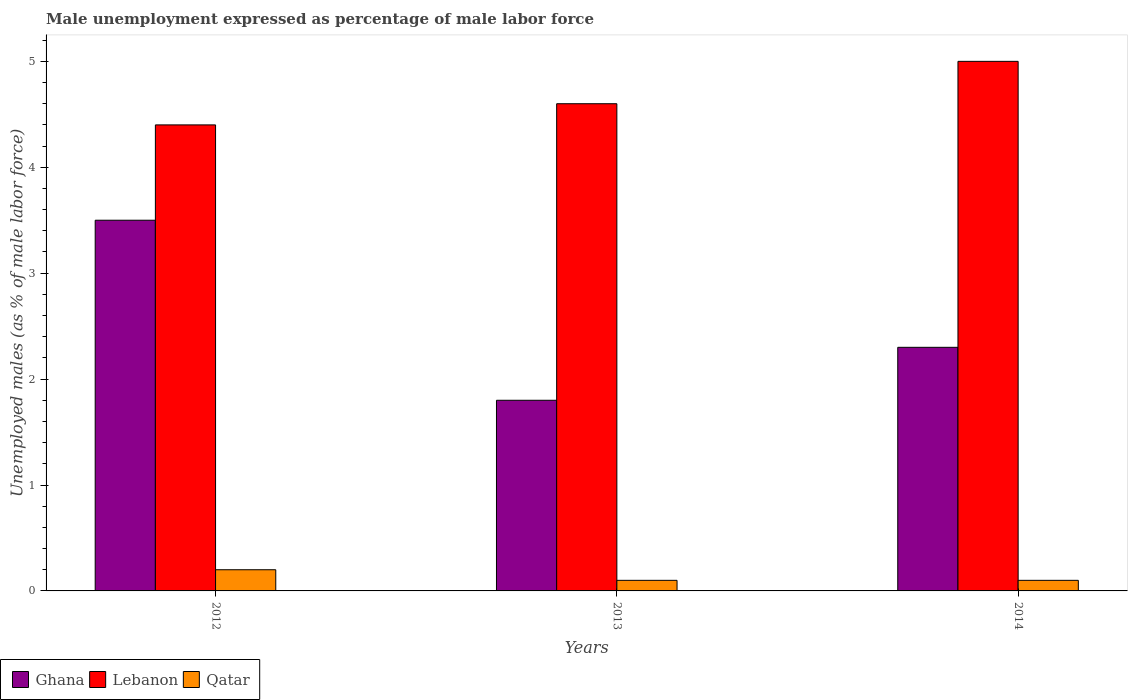How many groups of bars are there?
Your answer should be compact. 3. Are the number of bars on each tick of the X-axis equal?
Provide a succinct answer. Yes. What is the label of the 2nd group of bars from the left?
Your response must be concise. 2013. What is the unemployment in males in in Qatar in 2014?
Keep it short and to the point. 0.1. Across all years, what is the maximum unemployment in males in in Lebanon?
Your response must be concise. 5. Across all years, what is the minimum unemployment in males in in Lebanon?
Ensure brevity in your answer.  4.4. In which year was the unemployment in males in in Lebanon maximum?
Make the answer very short. 2014. What is the total unemployment in males in in Lebanon in the graph?
Offer a very short reply. 14. What is the difference between the unemployment in males in in Qatar in 2012 and that in 2014?
Make the answer very short. 0.1. What is the difference between the unemployment in males in in Ghana in 2012 and the unemployment in males in in Qatar in 2013?
Your answer should be compact. 3.4. What is the average unemployment in males in in Ghana per year?
Keep it short and to the point. 2.53. In the year 2013, what is the difference between the unemployment in males in in Ghana and unemployment in males in in Lebanon?
Ensure brevity in your answer.  -2.8. In how many years, is the unemployment in males in in Lebanon greater than 0.4 %?
Your answer should be compact. 3. What is the ratio of the unemployment in males in in Ghana in 2013 to that in 2014?
Give a very brief answer. 0.78. Is the unemployment in males in in Qatar in 2012 less than that in 2014?
Ensure brevity in your answer.  No. What is the difference between the highest and the second highest unemployment in males in in Ghana?
Keep it short and to the point. 1.2. What is the difference between the highest and the lowest unemployment in males in in Ghana?
Keep it short and to the point. 1.7. In how many years, is the unemployment in males in in Ghana greater than the average unemployment in males in in Ghana taken over all years?
Your answer should be compact. 1. What does the 3rd bar from the left in 2012 represents?
Ensure brevity in your answer.  Qatar. What does the 3rd bar from the right in 2014 represents?
Keep it short and to the point. Ghana. How many bars are there?
Ensure brevity in your answer.  9. Are all the bars in the graph horizontal?
Provide a succinct answer. No. How many years are there in the graph?
Give a very brief answer. 3. Does the graph contain any zero values?
Provide a short and direct response. No. How are the legend labels stacked?
Give a very brief answer. Horizontal. What is the title of the graph?
Give a very brief answer. Male unemployment expressed as percentage of male labor force. What is the label or title of the X-axis?
Ensure brevity in your answer.  Years. What is the label or title of the Y-axis?
Keep it short and to the point. Unemployed males (as % of male labor force). What is the Unemployed males (as % of male labor force) of Ghana in 2012?
Ensure brevity in your answer.  3.5. What is the Unemployed males (as % of male labor force) of Lebanon in 2012?
Provide a succinct answer. 4.4. What is the Unemployed males (as % of male labor force) in Qatar in 2012?
Give a very brief answer. 0.2. What is the Unemployed males (as % of male labor force) of Ghana in 2013?
Ensure brevity in your answer.  1.8. What is the Unemployed males (as % of male labor force) in Lebanon in 2013?
Provide a short and direct response. 4.6. What is the Unemployed males (as % of male labor force) of Qatar in 2013?
Make the answer very short. 0.1. What is the Unemployed males (as % of male labor force) in Ghana in 2014?
Give a very brief answer. 2.3. What is the Unemployed males (as % of male labor force) in Qatar in 2014?
Offer a terse response. 0.1. Across all years, what is the maximum Unemployed males (as % of male labor force) in Lebanon?
Make the answer very short. 5. Across all years, what is the maximum Unemployed males (as % of male labor force) of Qatar?
Give a very brief answer. 0.2. Across all years, what is the minimum Unemployed males (as % of male labor force) in Ghana?
Keep it short and to the point. 1.8. Across all years, what is the minimum Unemployed males (as % of male labor force) in Lebanon?
Offer a very short reply. 4.4. Across all years, what is the minimum Unemployed males (as % of male labor force) of Qatar?
Provide a succinct answer. 0.1. What is the total Unemployed males (as % of male labor force) in Lebanon in the graph?
Provide a short and direct response. 14. What is the difference between the Unemployed males (as % of male labor force) of Ghana in 2012 and that in 2014?
Ensure brevity in your answer.  1.2. What is the difference between the Unemployed males (as % of male labor force) in Ghana in 2013 and that in 2014?
Offer a terse response. -0.5. What is the difference between the Unemployed males (as % of male labor force) of Lebanon in 2013 and that in 2014?
Your answer should be very brief. -0.4. What is the difference between the Unemployed males (as % of male labor force) in Ghana in 2012 and the Unemployed males (as % of male labor force) in Lebanon in 2013?
Offer a terse response. -1.1. What is the difference between the Unemployed males (as % of male labor force) in Ghana in 2012 and the Unemployed males (as % of male labor force) in Qatar in 2014?
Your answer should be very brief. 3.4. What is the difference between the Unemployed males (as % of male labor force) of Lebanon in 2012 and the Unemployed males (as % of male labor force) of Qatar in 2014?
Give a very brief answer. 4.3. What is the difference between the Unemployed males (as % of male labor force) of Ghana in 2013 and the Unemployed males (as % of male labor force) of Lebanon in 2014?
Make the answer very short. -3.2. What is the difference between the Unemployed males (as % of male labor force) of Ghana in 2013 and the Unemployed males (as % of male labor force) of Qatar in 2014?
Your answer should be very brief. 1.7. What is the difference between the Unemployed males (as % of male labor force) in Lebanon in 2013 and the Unemployed males (as % of male labor force) in Qatar in 2014?
Keep it short and to the point. 4.5. What is the average Unemployed males (as % of male labor force) of Ghana per year?
Ensure brevity in your answer.  2.53. What is the average Unemployed males (as % of male labor force) in Lebanon per year?
Keep it short and to the point. 4.67. What is the average Unemployed males (as % of male labor force) in Qatar per year?
Make the answer very short. 0.13. In the year 2012, what is the difference between the Unemployed males (as % of male labor force) of Ghana and Unemployed males (as % of male labor force) of Lebanon?
Make the answer very short. -0.9. In the year 2012, what is the difference between the Unemployed males (as % of male labor force) of Lebanon and Unemployed males (as % of male labor force) of Qatar?
Your answer should be compact. 4.2. In the year 2014, what is the difference between the Unemployed males (as % of male labor force) of Ghana and Unemployed males (as % of male labor force) of Lebanon?
Your response must be concise. -2.7. What is the ratio of the Unemployed males (as % of male labor force) in Ghana in 2012 to that in 2013?
Your answer should be very brief. 1.94. What is the ratio of the Unemployed males (as % of male labor force) in Lebanon in 2012 to that in 2013?
Keep it short and to the point. 0.96. What is the ratio of the Unemployed males (as % of male labor force) of Ghana in 2012 to that in 2014?
Offer a very short reply. 1.52. What is the ratio of the Unemployed males (as % of male labor force) in Qatar in 2012 to that in 2014?
Offer a very short reply. 2. What is the ratio of the Unemployed males (as % of male labor force) of Ghana in 2013 to that in 2014?
Provide a succinct answer. 0.78. What is the ratio of the Unemployed males (as % of male labor force) in Lebanon in 2013 to that in 2014?
Provide a short and direct response. 0.92. What is the difference between the highest and the lowest Unemployed males (as % of male labor force) in Ghana?
Provide a short and direct response. 1.7. 